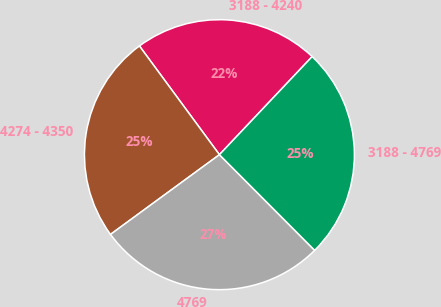Convert chart to OTSL. <chart><loc_0><loc_0><loc_500><loc_500><pie_chart><fcel>3188 - 4240<fcel>4274 - 4350<fcel>4769<fcel>3188 - 4769<nl><fcel>22.15%<fcel>24.96%<fcel>27.41%<fcel>25.48%<nl></chart> 